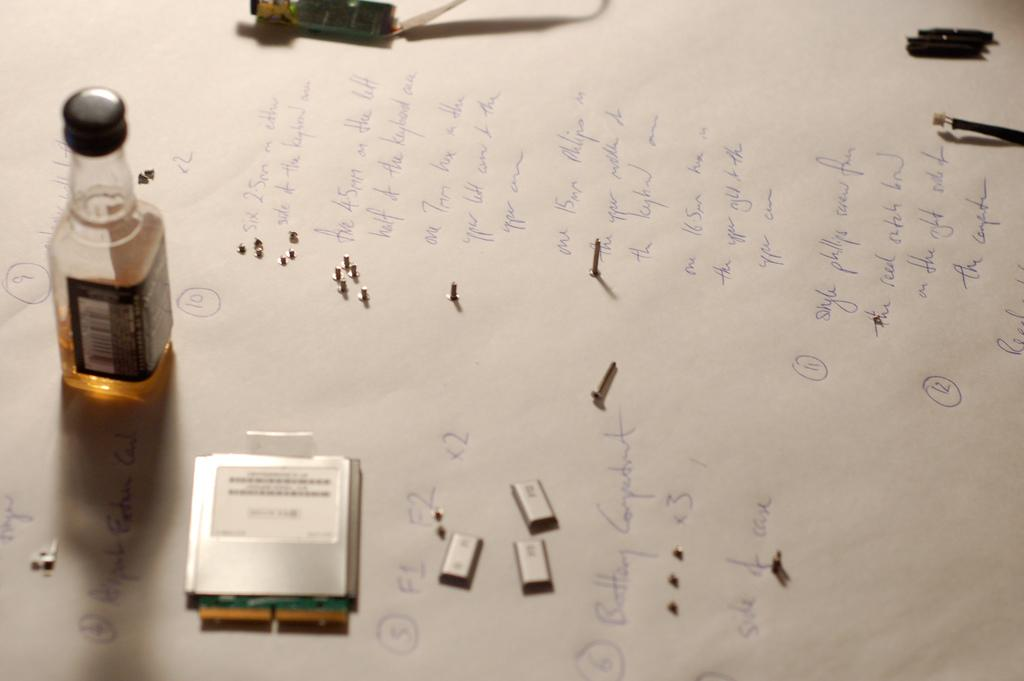What is present on the paper in the image? There is a bottle on the paper in the image. Can you describe the bottle in more detail? Unfortunately, the facts provided do not give any additional details about the bottle. What type of soup is being served in the image? There is no soup present in the image. The facts provided only mention a paper and a bottle on the paper. 